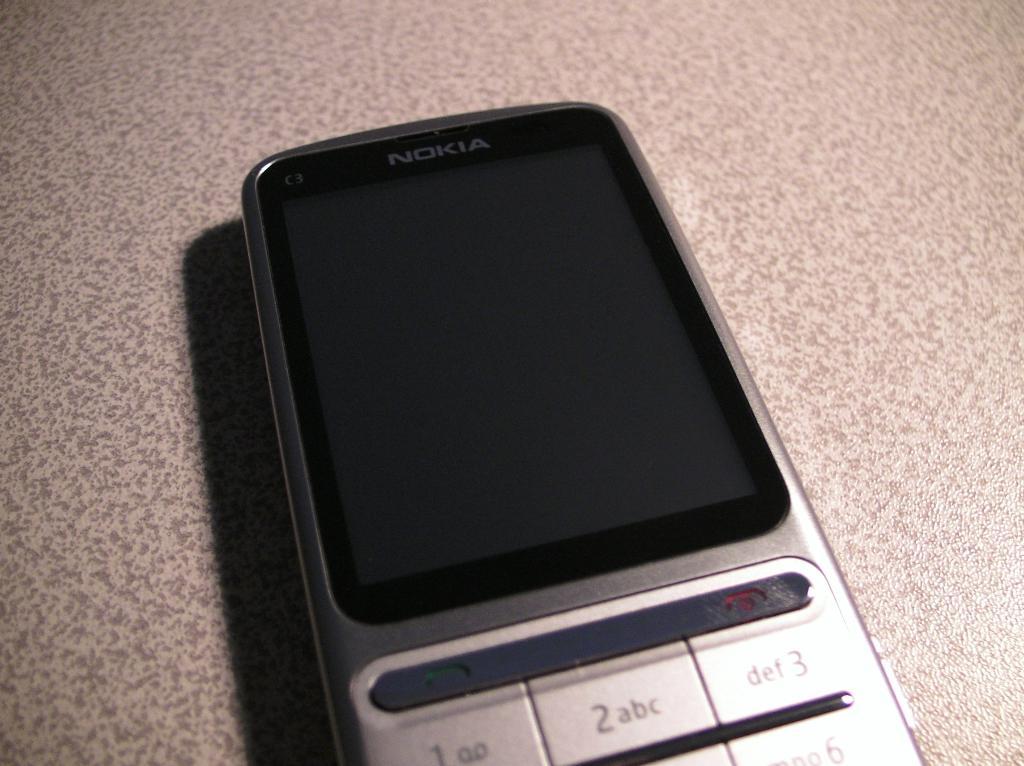What brand of phone is this?
Your answer should be very brief. Nokia. Is the phone on?
Keep it short and to the point. No. 